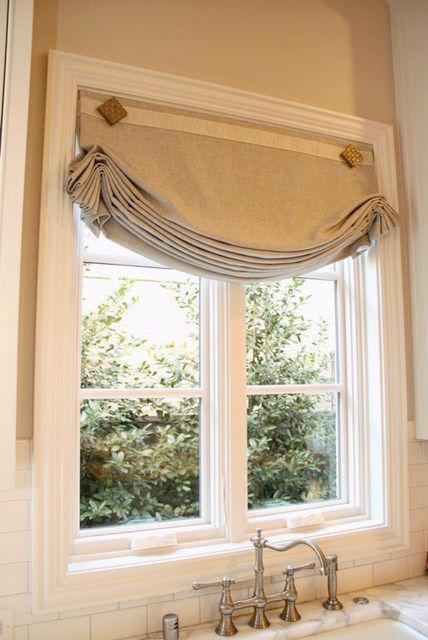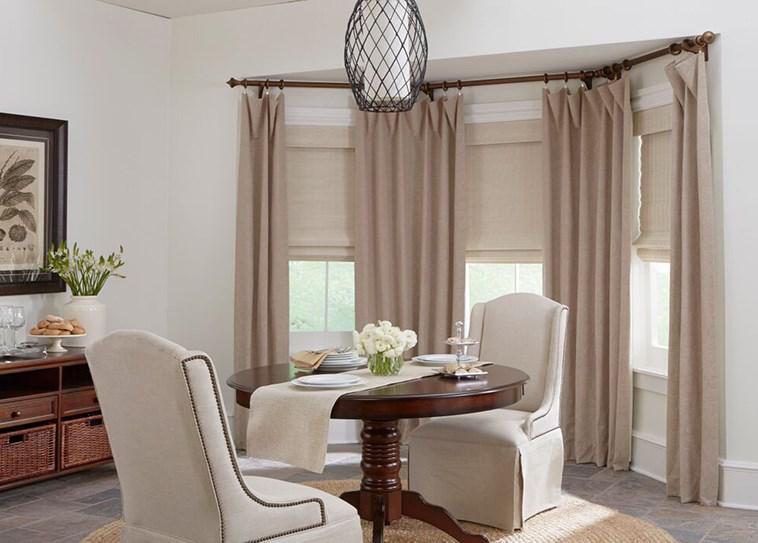The first image is the image on the left, the second image is the image on the right. For the images displayed, is the sentence "The right image features a room with at least three windows with rolled up shades printed with bold geometric patterns." factually correct? Answer yes or no. No. 